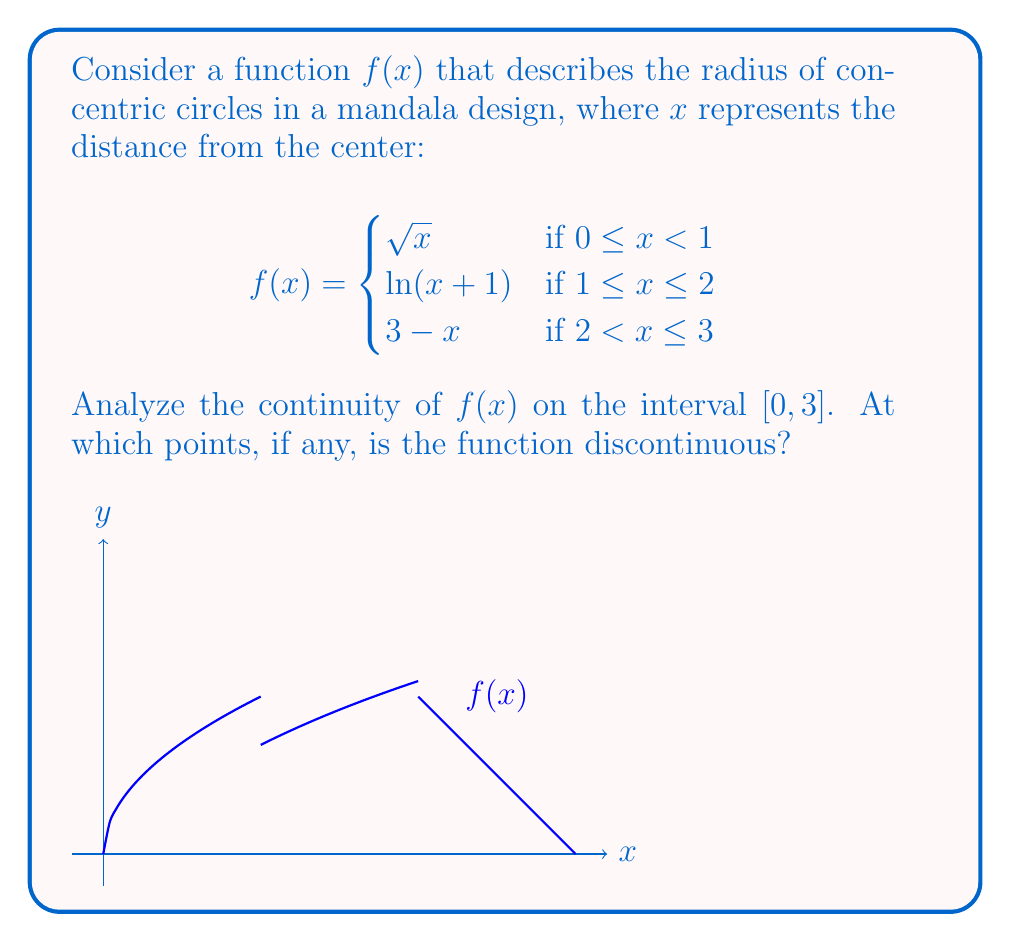Give your solution to this math problem. To analyze the continuity of $f(x)$ on $[0, 3]$, we need to check:
1. Continuity within each piece
2. Continuity at the transition points (x = 1 and x = 2)

Step 1: Continuity within each piece
- $\sqrt{x}$ is continuous on $[0, 1)$
- $\ln(x+1)$ is continuous on $[1, 2]$
- $3-x$ is continuous on $(2, 3]$

Step 2: Continuity at x = 1
Left limit: $\lim_{x \to 1^-} \sqrt{x} = 1$
Right limit: $\lim_{x \to 1^+} \ln(x+1) = \ln(2)$
$f(1) = \ln(2)$

Since $1 \neq \ln(2)$, there's a discontinuity at x = 1.

Step 3: Continuity at x = 2
Left limit: $\lim_{x \to 2^-} \ln(x+1) = \ln(3)$
Right limit: $\lim_{x \to 2^+} (3-x) = 1$
$f(2) = \ln(3)$

Since $\ln(3) \neq 1$, there's a discontinuity at x = 2.

Therefore, $f(x)$ is discontinuous at x = 1 and x = 2.
Answer: Discontinuous at x = 1 and x = 2 